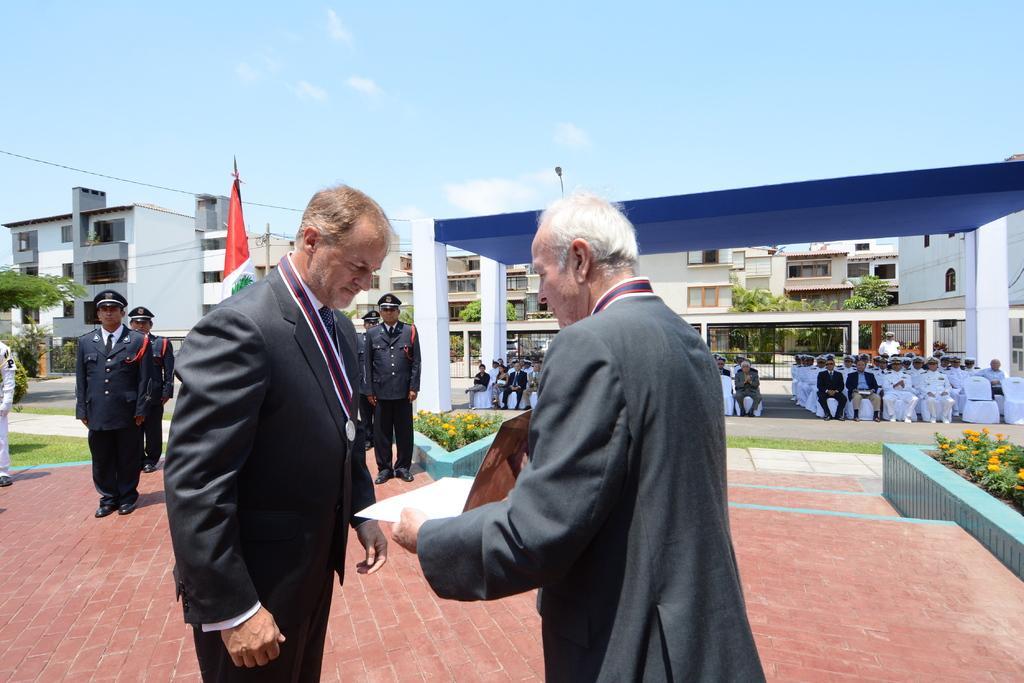Describe this image in one or two sentences. In this image we can see there are a few people standing and few people sitting on the chair. And we can see the person holding an object. We can see there are stairs, plants with flowers, flag, buildings, trees, grass and the sky. 